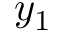Convert formula to latex. <formula><loc_0><loc_0><loc_500><loc_500>y _ { 1 }</formula> 